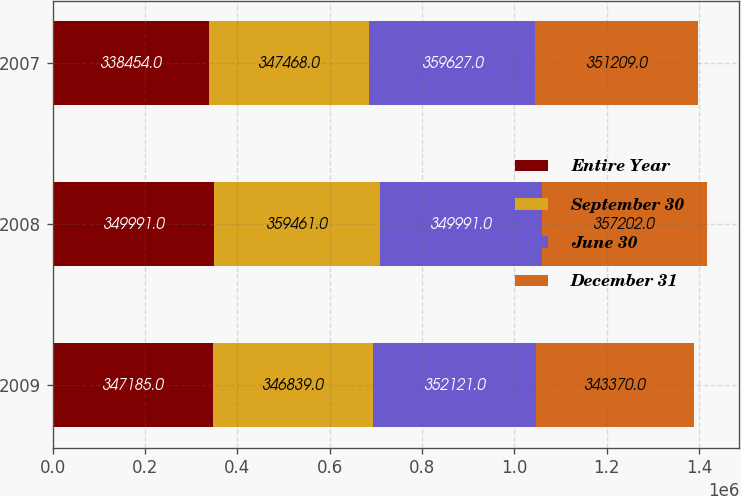<chart> <loc_0><loc_0><loc_500><loc_500><stacked_bar_chart><ecel><fcel>2009<fcel>2008<fcel>2007<nl><fcel>Entire Year<fcel>347185<fcel>349991<fcel>338454<nl><fcel>September 30<fcel>346839<fcel>359461<fcel>347468<nl><fcel>June 30<fcel>352121<fcel>349991<fcel>359627<nl><fcel>December 31<fcel>343370<fcel>357202<fcel>351209<nl></chart> 